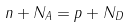Convert formula to latex. <formula><loc_0><loc_0><loc_500><loc_500>n + N _ { A } = p + N _ { D }</formula> 